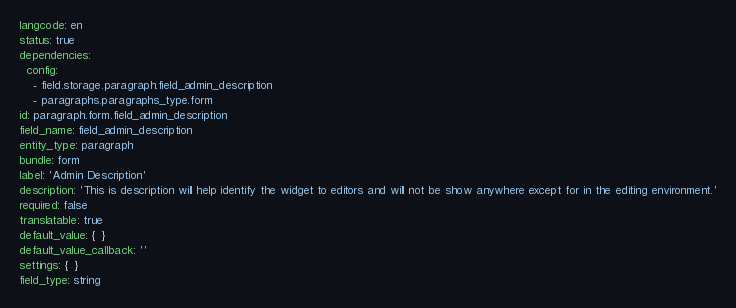Convert code to text. <code><loc_0><loc_0><loc_500><loc_500><_YAML_>langcode: en
status: true
dependencies:
  config:
    - field.storage.paragraph.field_admin_description
    - paragraphs.paragraphs_type.form
id: paragraph.form.field_admin_description
field_name: field_admin_description
entity_type: paragraph
bundle: form
label: 'Admin Description'
description: 'This is description will help identify the widget to editors and will not be show anywhere except for in the editing environment.'
required: false
translatable: true
default_value: {  }
default_value_callback: ''
settings: {  }
field_type: string
</code> 